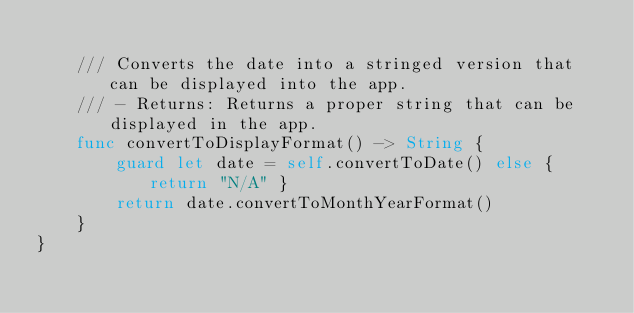Convert code to text. <code><loc_0><loc_0><loc_500><loc_500><_Swift_>    
    /// Converts the date into a stringed version that can be displayed into the app.
    /// - Returns: Returns a proper string that can be displayed in the app.
    func convertToDisplayFormat() -> String {
        guard let date = self.convertToDate() else { return "N/A" }
        return date.convertToMonthYearFormat()
    }
}
</code> 